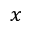Convert formula to latex. <formula><loc_0><loc_0><loc_500><loc_500>x</formula> 